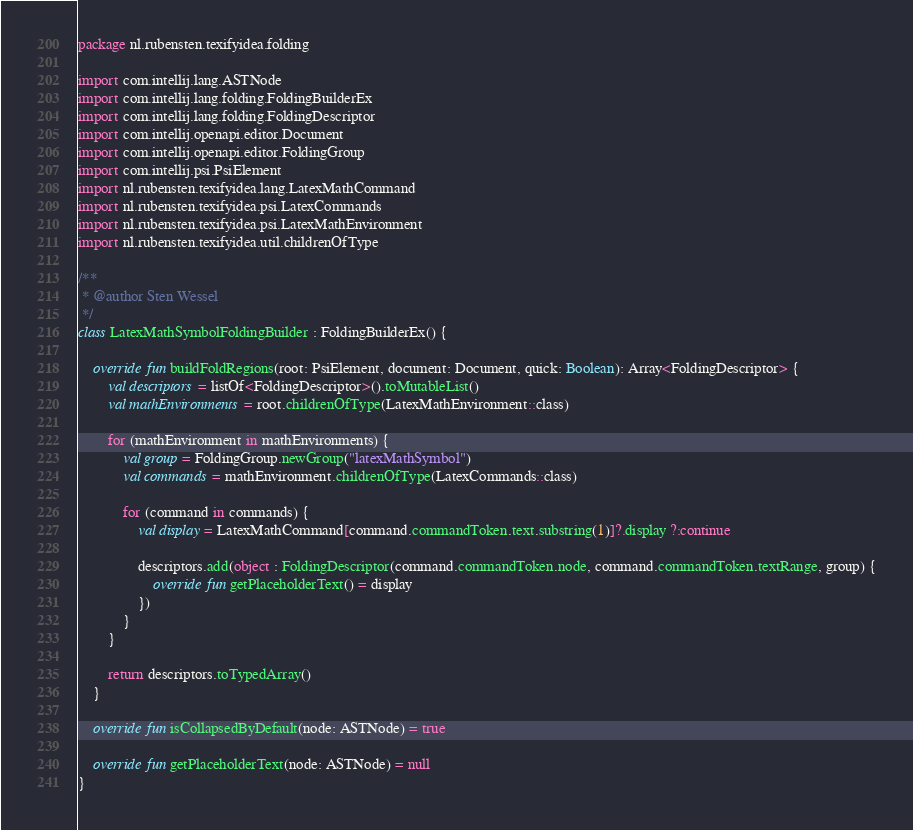<code> <loc_0><loc_0><loc_500><loc_500><_Kotlin_>package nl.rubensten.texifyidea.folding

import com.intellij.lang.ASTNode
import com.intellij.lang.folding.FoldingBuilderEx
import com.intellij.lang.folding.FoldingDescriptor
import com.intellij.openapi.editor.Document
import com.intellij.openapi.editor.FoldingGroup
import com.intellij.psi.PsiElement
import nl.rubensten.texifyidea.lang.LatexMathCommand
import nl.rubensten.texifyidea.psi.LatexCommands
import nl.rubensten.texifyidea.psi.LatexMathEnvironment
import nl.rubensten.texifyidea.util.childrenOfType

/**
 * @author Sten Wessel
 */
class LatexMathSymbolFoldingBuilder : FoldingBuilderEx() {

    override fun buildFoldRegions(root: PsiElement, document: Document, quick: Boolean): Array<FoldingDescriptor> {
        val descriptors = listOf<FoldingDescriptor>().toMutableList()
        val mathEnvironments = root.childrenOfType(LatexMathEnvironment::class)

        for (mathEnvironment in mathEnvironments) {
            val group = FoldingGroup.newGroup("latexMathSymbol")
            val commands = mathEnvironment.childrenOfType(LatexCommands::class)

            for (command in commands) {
                val display = LatexMathCommand[command.commandToken.text.substring(1)]?.display ?:continue

                descriptors.add(object : FoldingDescriptor(command.commandToken.node, command.commandToken.textRange, group) {
                    override fun getPlaceholderText() = display
                })
            }
        }

        return descriptors.toTypedArray()
    }

    override fun isCollapsedByDefault(node: ASTNode) = true

    override fun getPlaceholderText(node: ASTNode) = null
}
</code> 